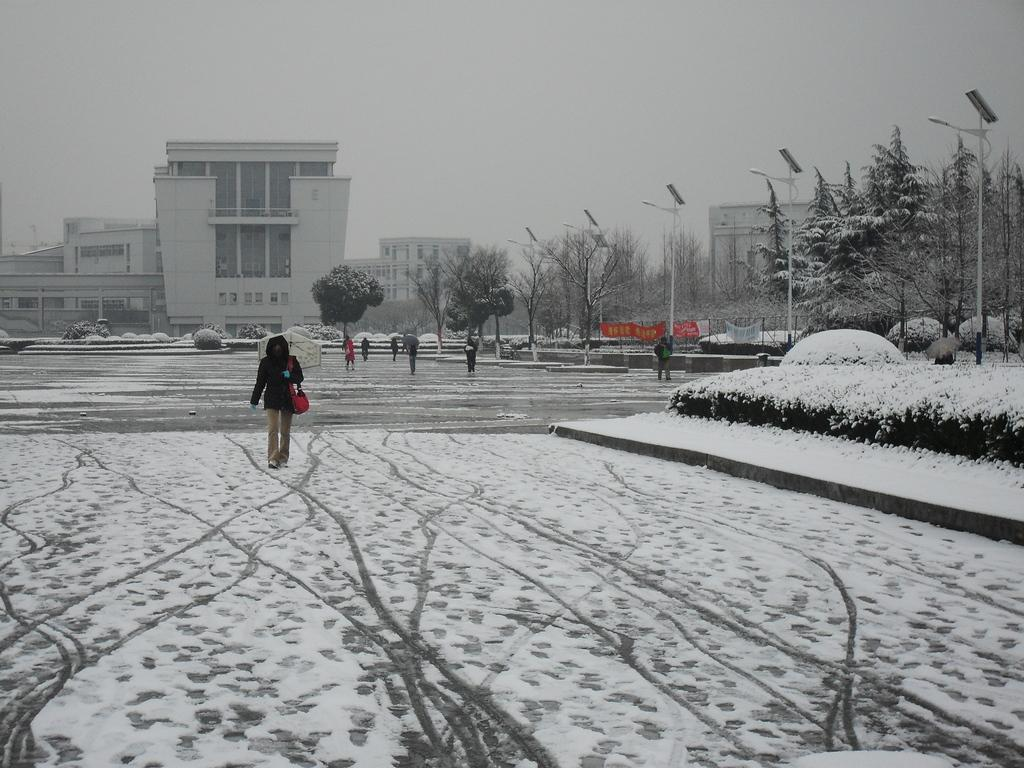Who is present in the image? There is a person in the image. What is the person wearing? The person is wearing a bag. What is the person doing in the image? The person is walking on a path. What is the weather like in the image? There is snow in the image. What can be seen in the background of the image? There are trees, street lights, and buildings in the background of the image. How many girls are pushing the person in the image? There are no girls present in the image, nor is anyone pushing the person. 